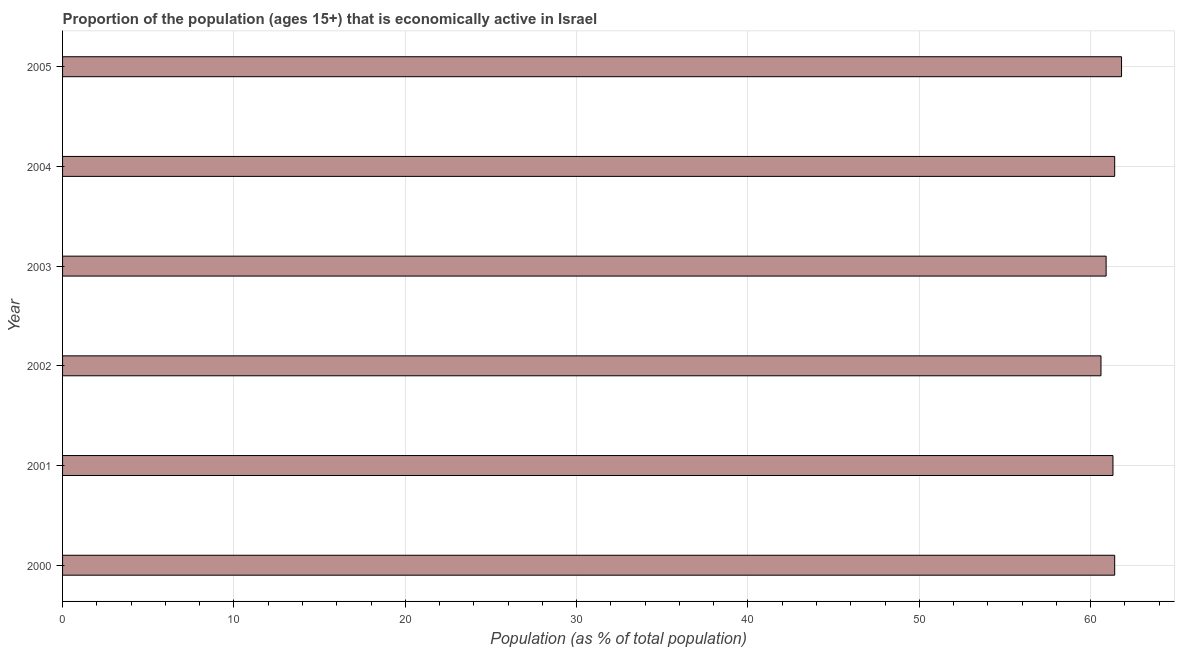Does the graph contain grids?
Ensure brevity in your answer.  Yes. What is the title of the graph?
Offer a very short reply. Proportion of the population (ages 15+) that is economically active in Israel. What is the label or title of the X-axis?
Give a very brief answer. Population (as % of total population). What is the label or title of the Y-axis?
Give a very brief answer. Year. What is the percentage of economically active population in 2005?
Offer a terse response. 61.8. Across all years, what is the maximum percentage of economically active population?
Your answer should be compact. 61.8. Across all years, what is the minimum percentage of economically active population?
Ensure brevity in your answer.  60.6. In which year was the percentage of economically active population maximum?
Keep it short and to the point. 2005. In which year was the percentage of economically active population minimum?
Offer a terse response. 2002. What is the sum of the percentage of economically active population?
Provide a succinct answer. 367.4. What is the difference between the percentage of economically active population in 2002 and 2005?
Your answer should be very brief. -1.2. What is the average percentage of economically active population per year?
Keep it short and to the point. 61.23. What is the median percentage of economically active population?
Offer a terse response. 61.35. Is the sum of the percentage of economically active population in 2001 and 2002 greater than the maximum percentage of economically active population across all years?
Your answer should be very brief. Yes. What is the difference between the highest and the lowest percentage of economically active population?
Provide a succinct answer. 1.2. In how many years, is the percentage of economically active population greater than the average percentage of economically active population taken over all years?
Offer a very short reply. 4. How many bars are there?
Provide a succinct answer. 6. Are all the bars in the graph horizontal?
Offer a terse response. Yes. How many years are there in the graph?
Make the answer very short. 6. What is the difference between two consecutive major ticks on the X-axis?
Provide a succinct answer. 10. Are the values on the major ticks of X-axis written in scientific E-notation?
Provide a succinct answer. No. What is the Population (as % of total population) in 2000?
Your answer should be very brief. 61.4. What is the Population (as % of total population) in 2001?
Your answer should be very brief. 61.3. What is the Population (as % of total population) in 2002?
Your response must be concise. 60.6. What is the Population (as % of total population) of 2003?
Offer a very short reply. 60.9. What is the Population (as % of total population) of 2004?
Make the answer very short. 61.4. What is the Population (as % of total population) of 2005?
Provide a short and direct response. 61.8. What is the difference between the Population (as % of total population) in 2000 and 2003?
Offer a terse response. 0.5. What is the difference between the Population (as % of total population) in 2000 and 2004?
Offer a very short reply. 0. What is the difference between the Population (as % of total population) in 2000 and 2005?
Your answer should be compact. -0.4. What is the difference between the Population (as % of total population) in 2001 and 2002?
Provide a succinct answer. 0.7. What is the difference between the Population (as % of total population) in 2001 and 2003?
Provide a short and direct response. 0.4. What is the difference between the Population (as % of total population) in 2001 and 2005?
Give a very brief answer. -0.5. What is the difference between the Population (as % of total population) in 2002 and 2003?
Your response must be concise. -0.3. What is the difference between the Population (as % of total population) in 2002 and 2005?
Provide a succinct answer. -1.2. What is the ratio of the Population (as % of total population) in 2000 to that in 2003?
Offer a very short reply. 1.01. What is the ratio of the Population (as % of total population) in 2001 to that in 2002?
Provide a succinct answer. 1.01. What is the ratio of the Population (as % of total population) in 2001 to that in 2003?
Keep it short and to the point. 1.01. What is the ratio of the Population (as % of total population) in 2001 to that in 2005?
Provide a short and direct response. 0.99. What is the ratio of the Population (as % of total population) in 2002 to that in 2003?
Keep it short and to the point. 0.99. What is the ratio of the Population (as % of total population) in 2002 to that in 2004?
Provide a succinct answer. 0.99. What is the ratio of the Population (as % of total population) in 2002 to that in 2005?
Ensure brevity in your answer.  0.98. What is the ratio of the Population (as % of total population) in 2003 to that in 2004?
Provide a short and direct response. 0.99. What is the ratio of the Population (as % of total population) in 2003 to that in 2005?
Your answer should be very brief. 0.98. 